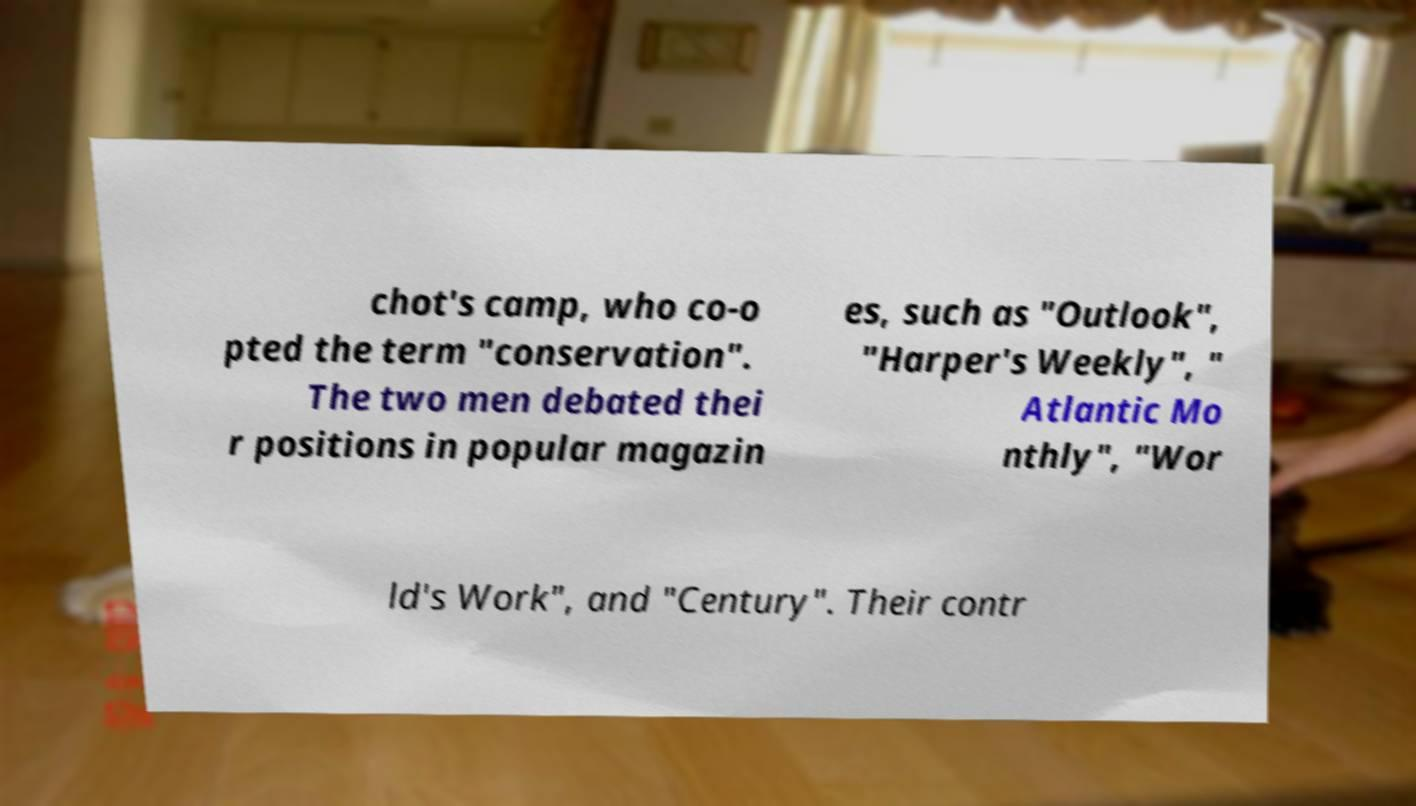Please identify and transcribe the text found in this image. chot's camp, who co-o pted the term "conservation". The two men debated thei r positions in popular magazin es, such as "Outlook", "Harper's Weekly", " Atlantic Mo nthly", "Wor ld's Work", and "Century". Their contr 